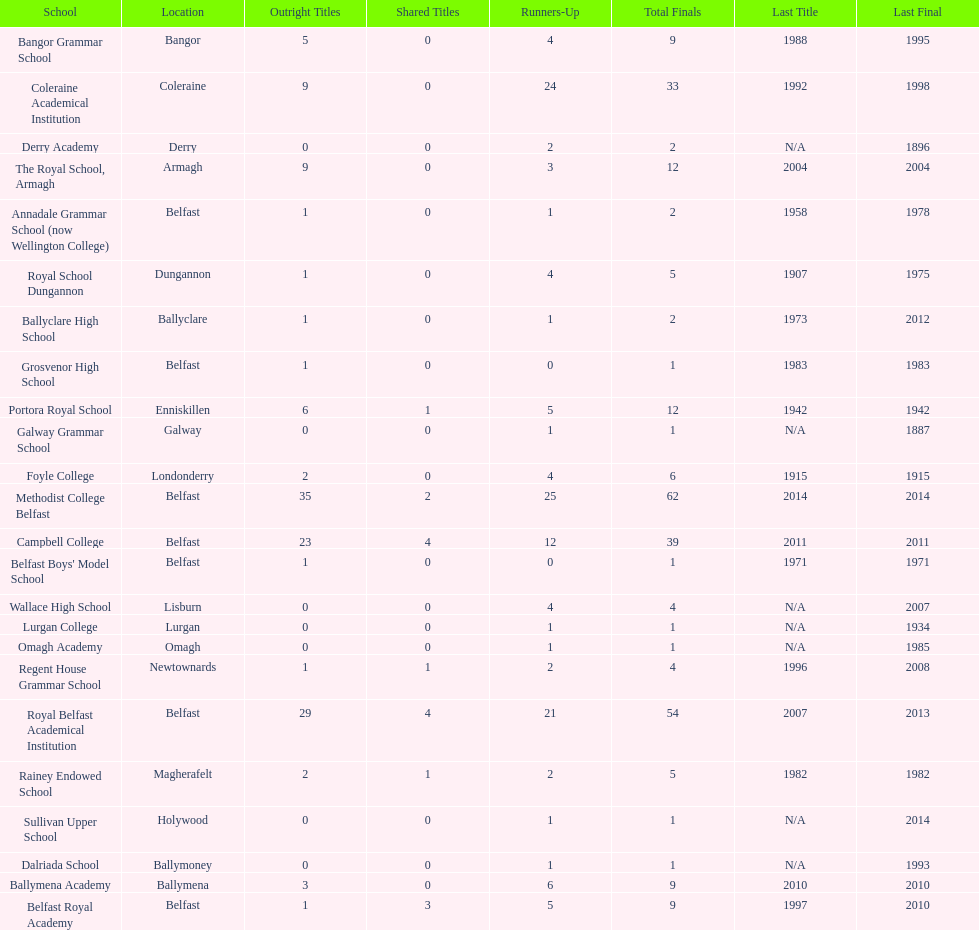Who has the most recent title win, campbell college or regent house grammar school? Campbell College. 